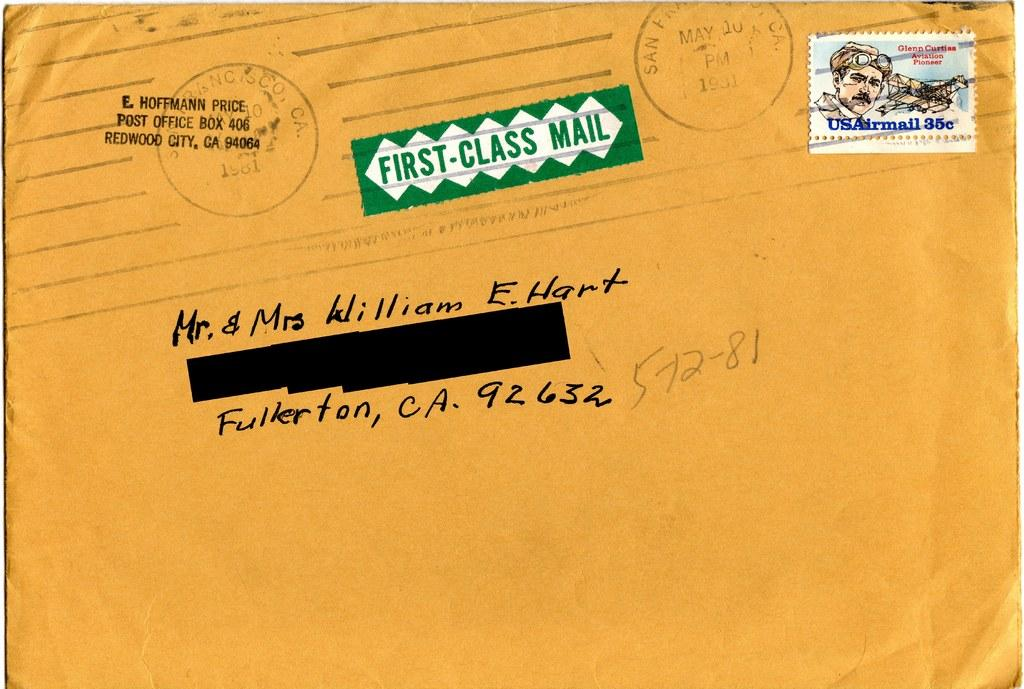What color is the prominent object in the image? The prominent object in the image is yellow. What is on the yellow object? The yellow object has text and stamps on it. What kind of images are on the yellow object? There is a picture of a person and pictures of other objects on the yellow object. Is there any blood visible on the yellow object in the image? No, there is no blood visible on the yellow object in the image. What type of curtain is hanging near the yellow object? There is no curtain present in the image. 